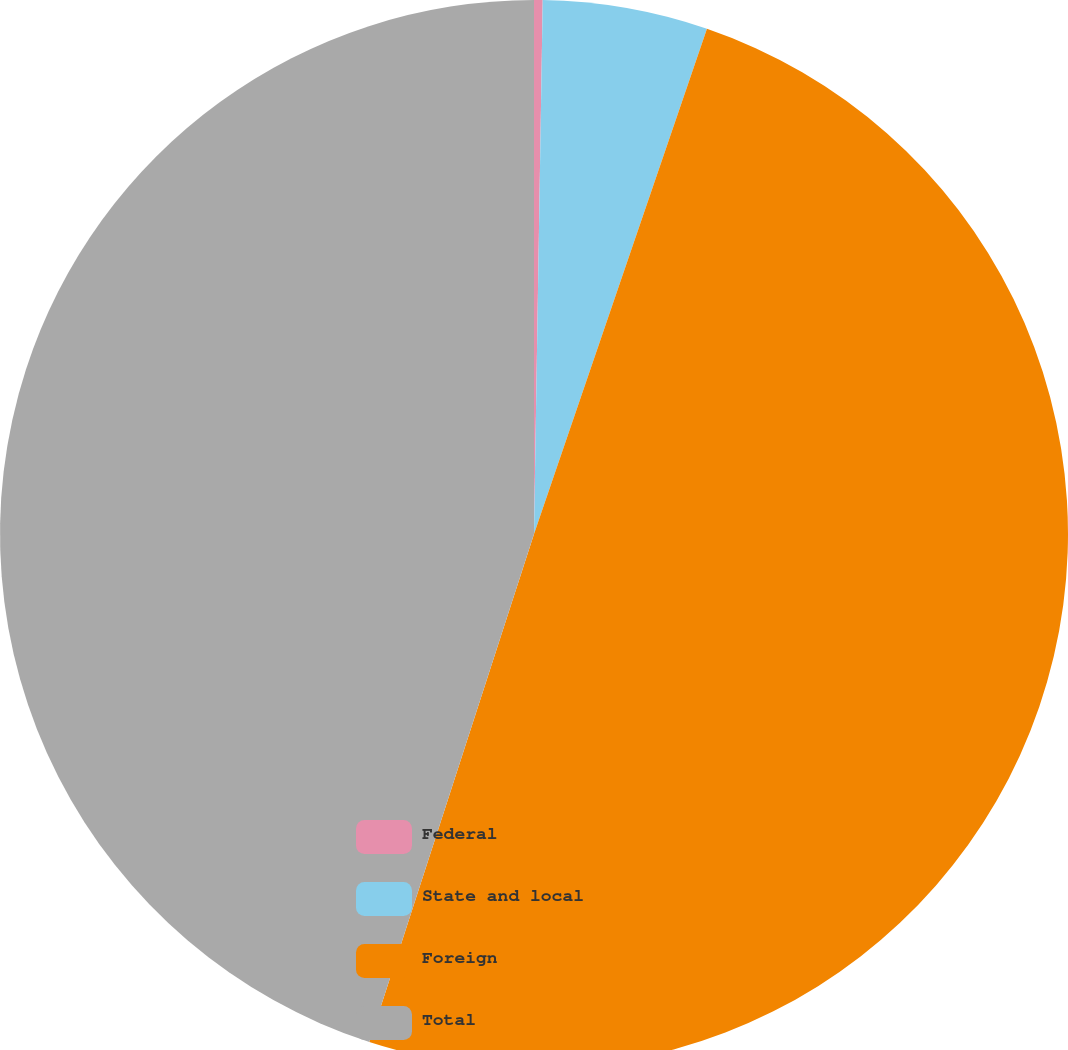Convert chart to OTSL. <chart><loc_0><loc_0><loc_500><loc_500><pie_chart><fcel>Federal<fcel>State and local<fcel>Foreign<fcel>Total<nl><fcel>0.26%<fcel>4.99%<fcel>49.74%<fcel>45.01%<nl></chart> 